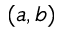Convert formula to latex. <formula><loc_0><loc_0><loc_500><loc_500>( a , b )</formula> 